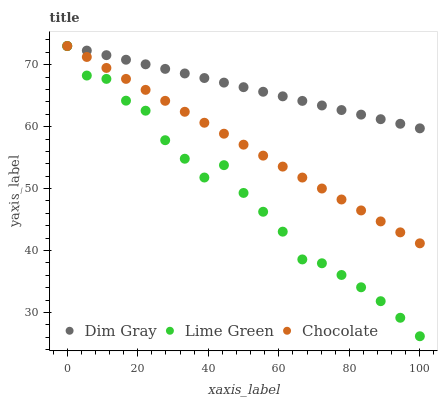Does Lime Green have the minimum area under the curve?
Answer yes or no. Yes. Does Dim Gray have the maximum area under the curve?
Answer yes or no. Yes. Does Chocolate have the minimum area under the curve?
Answer yes or no. No. Does Chocolate have the maximum area under the curve?
Answer yes or no. No. Is Dim Gray the smoothest?
Answer yes or no. Yes. Is Lime Green the roughest?
Answer yes or no. Yes. Is Chocolate the smoothest?
Answer yes or no. No. Is Chocolate the roughest?
Answer yes or no. No. Does Lime Green have the lowest value?
Answer yes or no. Yes. Does Chocolate have the lowest value?
Answer yes or no. No. Does Chocolate have the highest value?
Answer yes or no. Yes. Does Lime Green intersect Chocolate?
Answer yes or no. Yes. Is Lime Green less than Chocolate?
Answer yes or no. No. Is Lime Green greater than Chocolate?
Answer yes or no. No. 